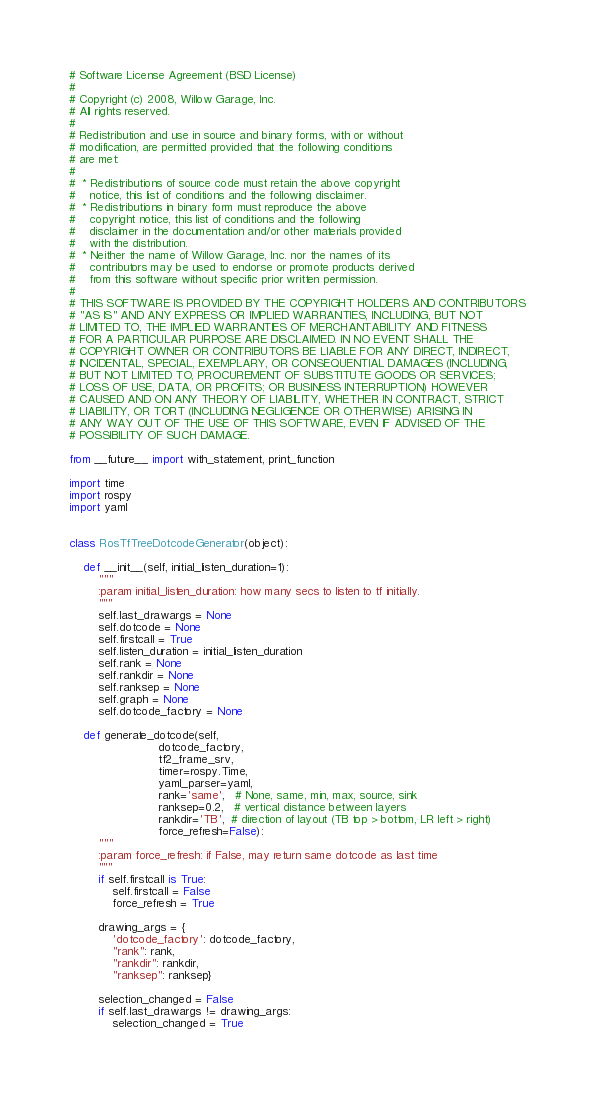Convert code to text. <code><loc_0><loc_0><loc_500><loc_500><_Python_># Software License Agreement (BSD License)
#
# Copyright (c) 2008, Willow Garage, Inc.
# All rights reserved.
#
# Redistribution and use in source and binary forms, with or without
# modification, are permitted provided that the following conditions
# are met:
#
#  * Redistributions of source code must retain the above copyright
#    notice, this list of conditions and the following disclaimer.
#  * Redistributions in binary form must reproduce the above
#    copyright notice, this list of conditions and the following
#    disclaimer in the documentation and/or other materials provided
#    with the distribution.
#  * Neither the name of Willow Garage, Inc. nor the names of its
#    contributors may be used to endorse or promote products derived
#    from this software without specific prior written permission.
#
# THIS SOFTWARE IS PROVIDED BY THE COPYRIGHT HOLDERS AND CONTRIBUTORS
# "AS IS" AND ANY EXPRESS OR IMPLIED WARRANTIES, INCLUDING, BUT NOT
# LIMITED TO, THE IMPLIED WARRANTIES OF MERCHANTABILITY AND FITNESS
# FOR A PARTICULAR PURPOSE ARE DISCLAIMED. IN NO EVENT SHALL THE
# COPYRIGHT OWNER OR CONTRIBUTORS BE LIABLE FOR ANY DIRECT, INDIRECT,
# INCIDENTAL, SPECIAL, EXEMPLARY, OR CONSEQUENTIAL DAMAGES (INCLUDING,
# BUT NOT LIMITED TO, PROCUREMENT OF SUBSTITUTE GOODS OR SERVICES;
# LOSS OF USE, DATA, OR PROFITS; OR BUSINESS INTERRUPTION) HOWEVER
# CAUSED AND ON ANY THEORY OF LIABILITY, WHETHER IN CONTRACT, STRICT
# LIABILITY, OR TORT (INCLUDING NEGLIGENCE OR OTHERWISE) ARISING IN
# ANY WAY OUT OF THE USE OF THIS SOFTWARE, EVEN IF ADVISED OF THE
# POSSIBILITY OF SUCH DAMAGE.

from __future__ import with_statement, print_function

import time
import rospy
import yaml


class RosTfTreeDotcodeGenerator(object):

    def __init__(self, initial_listen_duration=1):
        """
        :param initial_listen_duration: how many secs to listen to tf initially.
        """
        self.last_drawargs = None
        self.dotcode = None
        self.firstcall = True
        self.listen_duration = initial_listen_duration
        self.rank = None
        self.rankdir = None
        self.ranksep = None
        self.graph = None
        self.dotcode_factory = None

    def generate_dotcode(self,
                         dotcode_factory,
                         tf2_frame_srv,
                         timer=rospy.Time,
                         yaml_parser=yaml,
                         rank='same',   # None, same, min, max, source, sink
                         ranksep=0.2,   # vertical distance between layers
                         rankdir='TB',  # direction of layout (TB top > bottom, LR left > right)
                         force_refresh=False):
        """
        :param force_refresh: if False, may return same dotcode as last time
        """
        if self.firstcall is True:
            self.firstcall = False
            force_refresh = True

        drawing_args = {
            'dotcode_factory': dotcode_factory,
            "rank": rank,
            "rankdir": rankdir,
            "ranksep": ranksep}

        selection_changed = False
        if self.last_drawargs != drawing_args:
            selection_changed = True</code> 